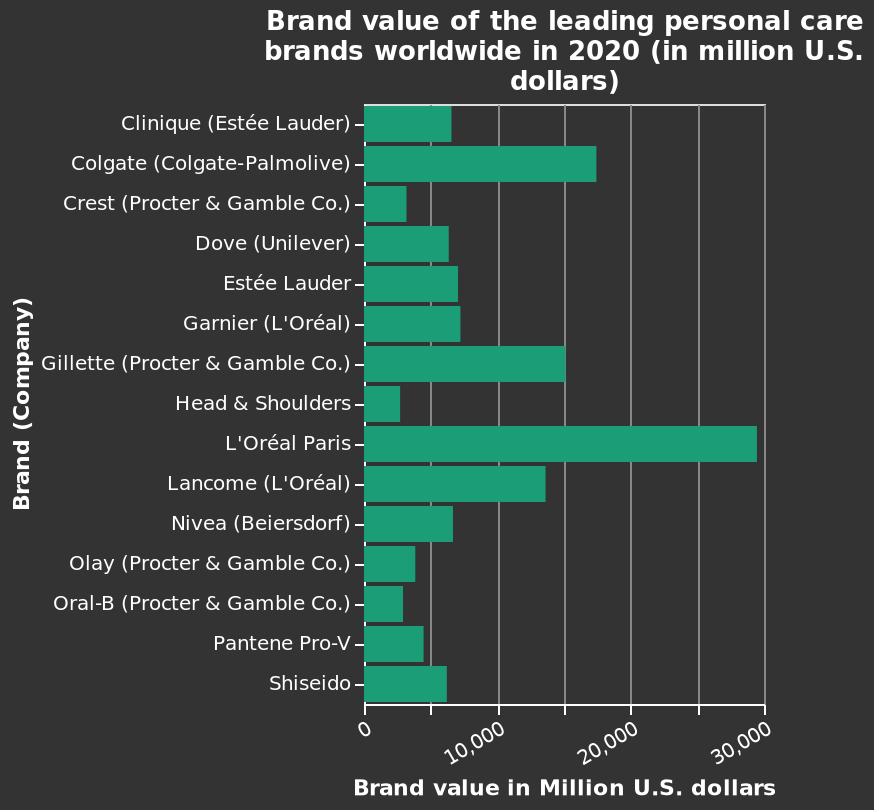<image>
Are there any other companies mentioned in the figure as competitors? No, there is no mention of other companies as competitors in the figure. Offer a thorough analysis of the image. I can see that L'Oréal paris are way out in the front, with their sister company not far behind. What does the x-axis measure in the bar diagram?  The x-axis measures Brand value in Million U.S. dollars. please summary the statistics and relations of the chart L’Oreal Paris is worth a huge amount more than every other company. In which year was the data collected for the bar diagram? The data for the bar diagram represents the Brand value of leading personal care brands worldwide in 2020. Describe the following image in detail Here a bar diagram is named Brand value of the leading personal care brands worldwide in 2020 (in million U.S. dollars). The x-axis measures Brand value in Million U.S. dollars while the y-axis shows Brand (Company). 